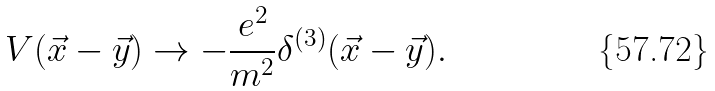<formula> <loc_0><loc_0><loc_500><loc_500>V ( \vec { x } - \vec { y } ) \to - \frac { e ^ { 2 } } { m ^ { 2 } } \delta ^ { ( 3 ) } ( \vec { x } - \vec { y } ) .</formula> 